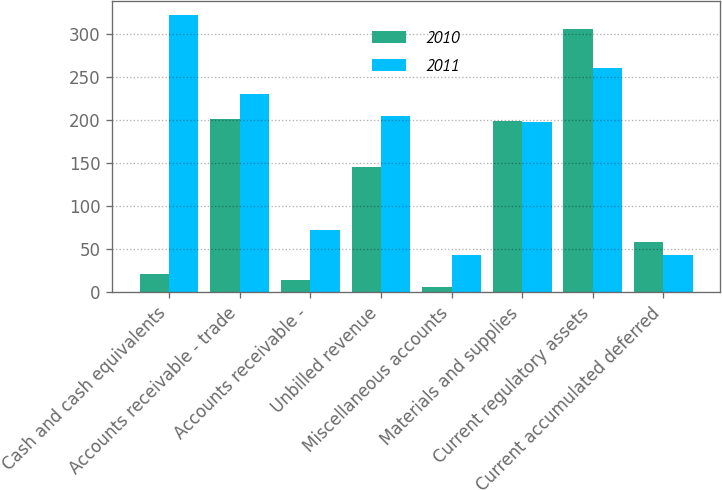<chart> <loc_0><loc_0><loc_500><loc_500><stacked_bar_chart><ecel><fcel>Cash and cash equivalents<fcel>Accounts receivable - trade<fcel>Accounts receivable -<fcel>Unbilled revenue<fcel>Miscellaneous accounts<fcel>Materials and supplies<fcel>Current regulatory assets<fcel>Current accumulated deferred<nl><fcel>2010<fcel>21<fcel>201<fcel>15<fcel>146<fcel>6<fcel>199<fcel>306<fcel>58<nl><fcel>2011<fcel>322<fcel>230<fcel>73<fcel>205<fcel>44<fcel>198<fcel>260<fcel>43<nl></chart> 